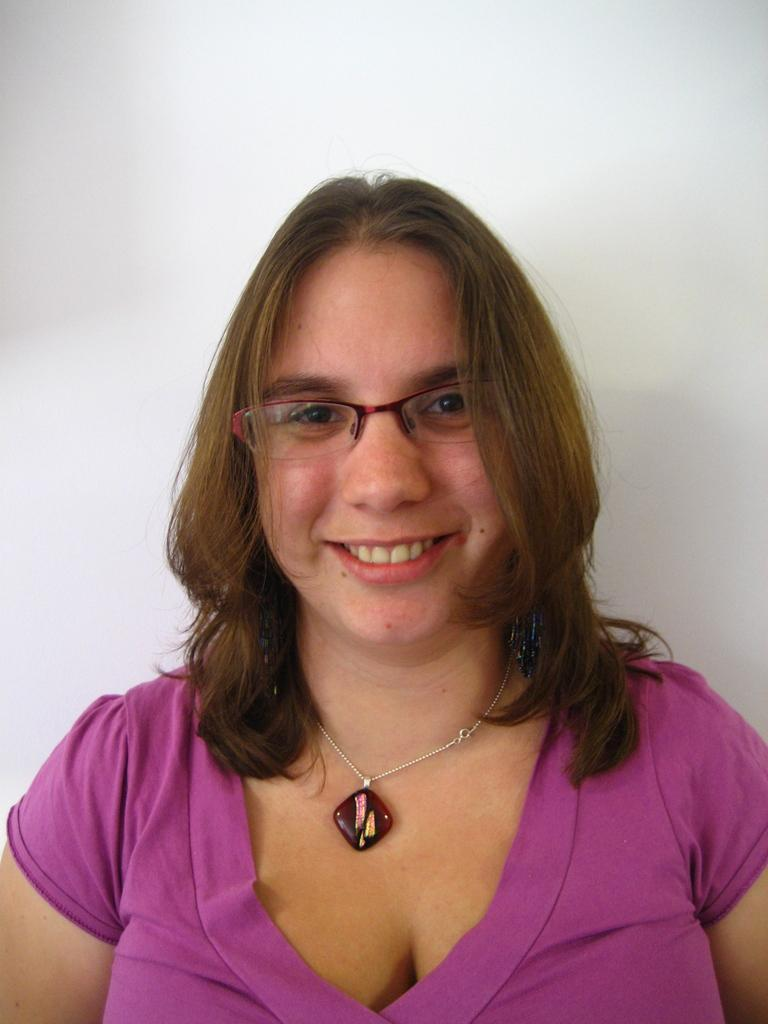What is the main subject of the image? The main subject of the image is a woman. What is the woman wearing in the image? The woman is wearing a pink dress. What can be seen in the background of the image? There is a wall in the background of the image. What type of attraction is the woman operating in the image? There is no indication in the image that the woman is operating an attraction, as the facts provided do not mention any such activity. 